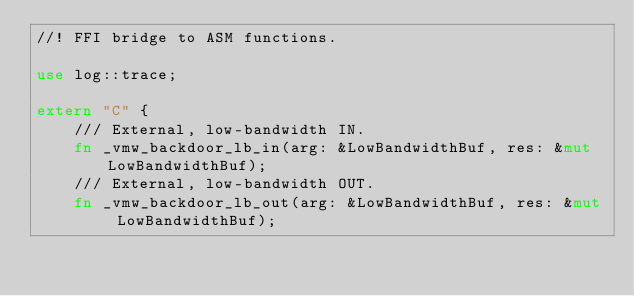Convert code to text. <code><loc_0><loc_0><loc_500><loc_500><_Rust_>//! FFI bridge to ASM functions.

use log::trace;

extern "C" {
    /// External, low-bandwidth IN.
    fn _vmw_backdoor_lb_in(arg: &LowBandwidthBuf, res: &mut LowBandwidthBuf);
    /// External, low-bandwidth OUT.
    fn _vmw_backdoor_lb_out(arg: &LowBandwidthBuf, res: &mut LowBandwidthBuf);
</code> 